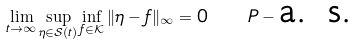Convert formula to latex. <formula><loc_0><loc_0><loc_500><loc_500>\lim _ { t \to \infty } \sup _ { \eta \in \mathcal { S } ( t ) } \inf _ { f \in \mathcal { K } } \| \eta - f \| _ { \infty } = 0 \quad P - \text {a. s.}</formula> 